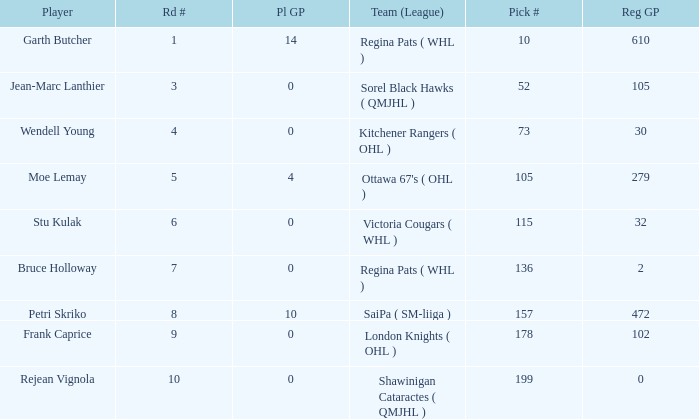What is the mean road number when Moe Lemay is the player? 5.0. 